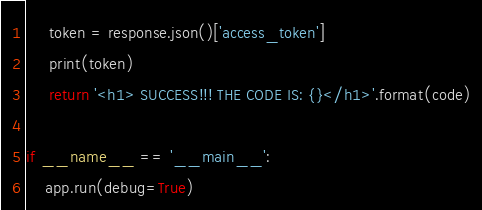Convert code to text. <code><loc_0><loc_0><loc_500><loc_500><_Python_>     token = response.json()['access_token']
     print(token)
     return '<h1> SUCCESS!!! THE CODE IS: {}</h1>'.format(code)

if __name__ == '__main__':
    app.run(debug=True)</code> 